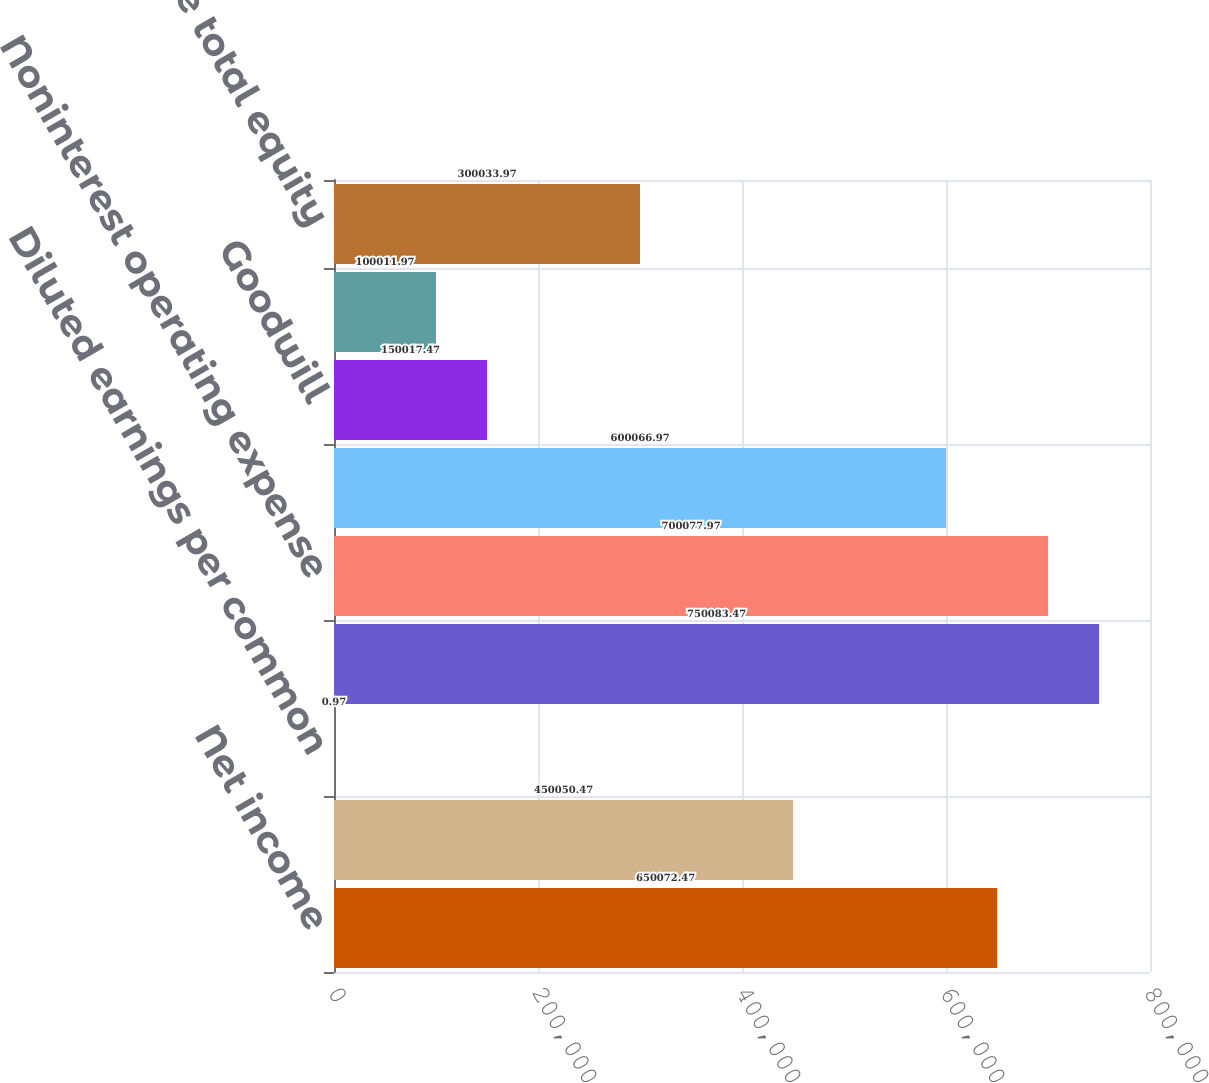Convert chart. <chart><loc_0><loc_0><loc_500><loc_500><bar_chart><fcel>Net income<fcel>Amortization of core deposit<fcel>Diluted earnings per common<fcel>Other expense<fcel>Noninterest operating expense<fcel>Average assets Average assets<fcel>Goodwill<fcel>Core deposit and other<fcel>Average total equity<nl><fcel>650072<fcel>450050<fcel>0.97<fcel>750083<fcel>700078<fcel>600067<fcel>150017<fcel>100012<fcel>300034<nl></chart> 